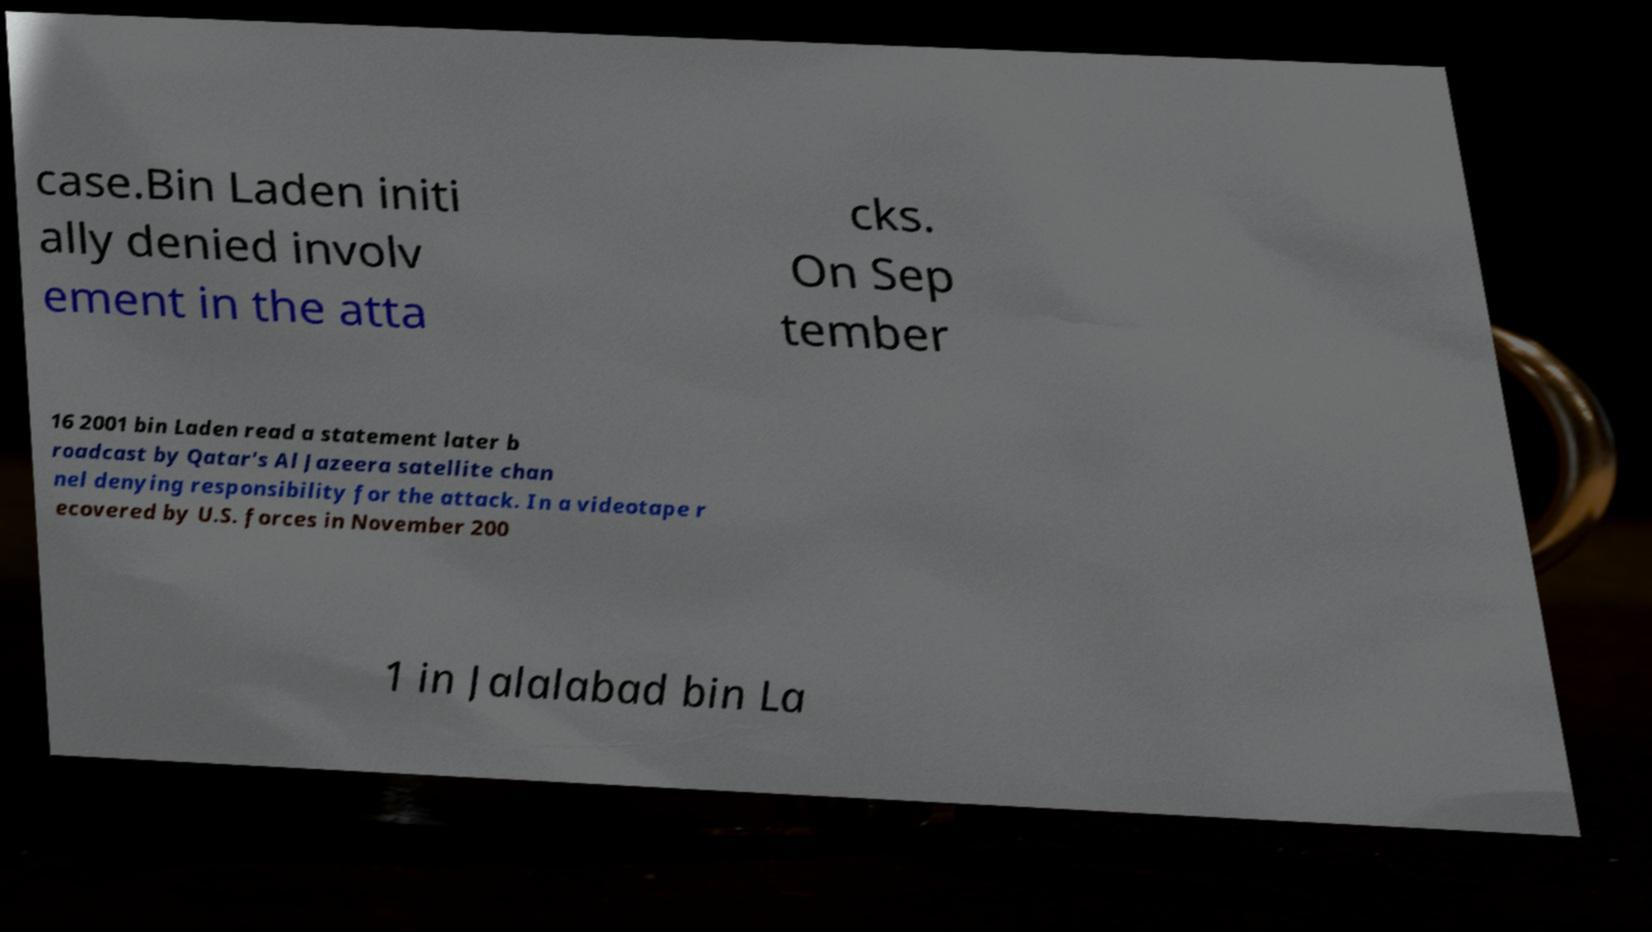Could you assist in decoding the text presented in this image and type it out clearly? case.Bin Laden initi ally denied involv ement in the atta cks. On Sep tember 16 2001 bin Laden read a statement later b roadcast by Qatar's Al Jazeera satellite chan nel denying responsibility for the attack. In a videotape r ecovered by U.S. forces in November 200 1 in Jalalabad bin La 